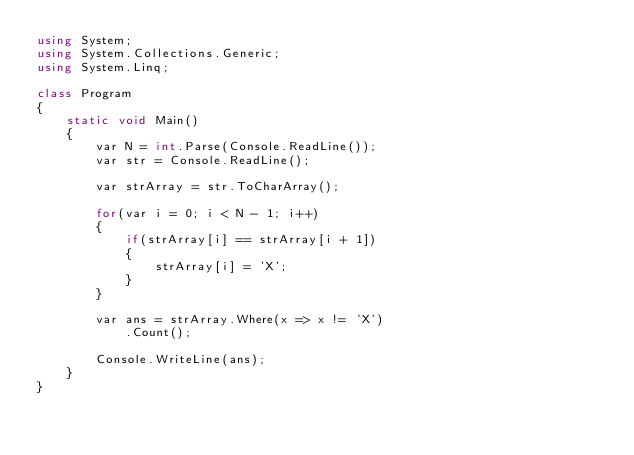Convert code to text. <code><loc_0><loc_0><loc_500><loc_500><_C#_>using System;
using System.Collections.Generic;
using System.Linq;

class Program
{
    static void Main()
    {
        var N = int.Parse(Console.ReadLine());
        var str = Console.ReadLine();

        var strArray = str.ToCharArray();

        for(var i = 0; i < N - 1; i++)
        {
            if(strArray[i] == strArray[i + 1])
            {
                strArray[i] = 'X';
            }
        }

        var ans = strArray.Where(x => x != 'X')
            .Count();

        Console.WriteLine(ans);
    }
}
</code> 